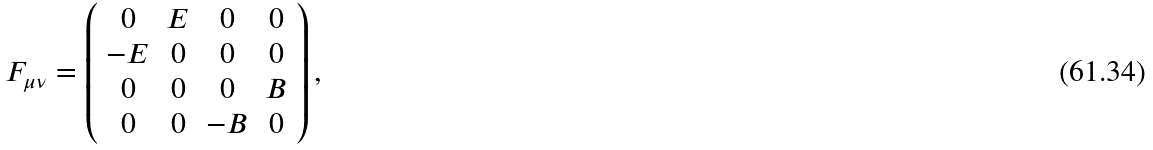<formula> <loc_0><loc_0><loc_500><loc_500>F _ { \mu \nu } = \left ( \begin{array} { c c c c } 0 & E & 0 & 0 \\ - E & 0 & 0 & 0 \\ 0 & 0 & 0 & B \\ 0 & 0 & - B & 0 \end{array} \right ) ,</formula> 